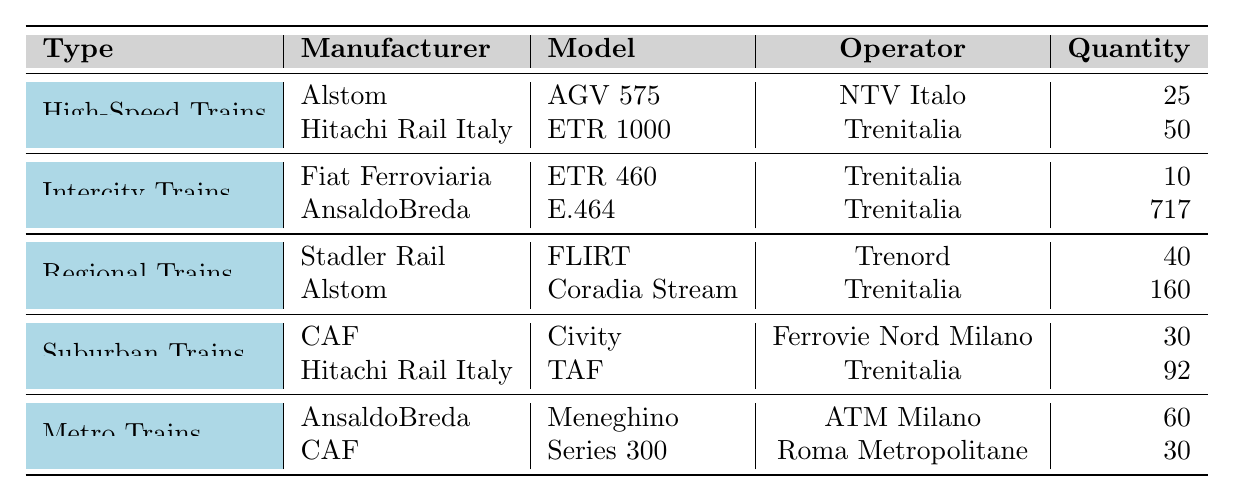What is the total quantity of High-Speed Trains? There are two models of High-Speed Trains: AGV 575 with a quantity of 25 and ETR 1000 with a quantity of 50. Adding these gives us 25 + 50 = 75.
Answer: 75 Which manufacturer provides the most Intercity Trains? Two manufacturers provide Intercity Trains: Fiat Ferroviaria with 10 units and AnsaldoBreda with 717 units. Since 717 is greater than 10, AnsaldoBreda provides the most Intercity Trains.
Answer: AnsaldoBreda How many Regional Trains are operated by Trenitalia? There are two models of Regional Trains operated by Trenitalia: Coradia Stream with 160 units and FLIRT operated by Trenord. Since only Coradia Stream operates under Trenitalia, we only consider this model and take the quantity 160.
Answer: 160 What type of trains does CAF manufacture? Looking at the table, CAF manufactures only Suburban Trains and Metro Trains, as indicated by the Civity and Series 300 models.
Answer: Suburban and Metro Trains Which operating company operates the most quantity of trains? To find this, I need to check the total quantity of trains operated by each company. Trenitalia operates 50 (ETR 1000) + 10 (ETR 460) + 717 (E.464) + 160 (Coradia Stream) + 92 (TAF) = 1029 trains. NTV Italo has 25 (AGV 575), Trenord has 40 (FLIRT), Ferrovie Nord Milano has 30 (Civity), ATM Milano has 60 (Meneghino), and Roma Metropolitane has 30 (Series 300). The greatest total is by Trenitalia with 1029.
Answer: Trenitalia How many different types of trains does Alstom manufacture? Examining the table, Alstom is listed under both High-Speed Trains and Regional Trains. Thus, there are two different types of trains manufactured by Alstom.
Answer: 2 If we combine the quantities of all Metro Trains, what is the total? The two models of Metro Trains are Meneghino (60 units) and Series 300 (30 units). To find the total, I will calculate 60 + 30 = 90.
Answer: 90 Is there a type of train that has no entries under the CAF manufacturer? The table shows that CAF manufactures Suburban Trains (Civity) and Metro Trains (Series 300), indicating that there are no other types of trains missing from CAF’s lineup. Hence, the answer is No.
Answer: No What percentage of the total train quantity is represented by Intercity Trains? First, I will calculate the total trains from all types: 75 (High-Speed) + 727 (Intercity) + 200 (Regional) + 122 (Suburban) + 90 (Metro) = 1214 trains. Next, Intercity Trains from the table total 727, and to find the percentage: (727 / 1214) * 100 ≈ 59.9%.
Answer: Approximately 59.9% Which type of train has the highest individual model quantity? Examining each model's quantity, I find that E.464 has 717 units, which is higher than any other model's quantity.
Answer: E.464 Are there more trains manufactured by Stadler Rail or Hitachi Rail Italy? Stadler Rail has 40 trains (FLIRT), while Hitachi Rail Italy has 50 (ETR 1000) and 92 (TAF), totaling 142 trains. Comparing these values shows that Hitachi Rail Italy has more.
Answer: Hitachi Rail Italy 